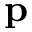Convert formula to latex. <formula><loc_0><loc_0><loc_500><loc_500>p</formula> 